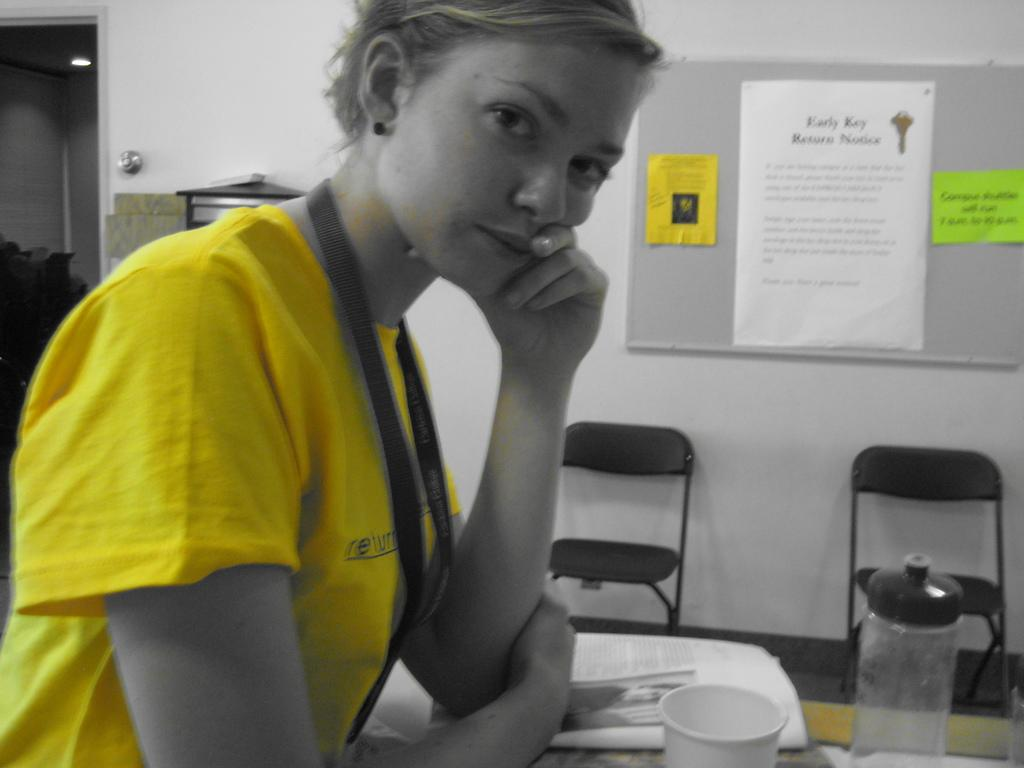<image>
Write a terse but informative summary of the picture. A blurry photo shows a billboard with an "early key return notice." 